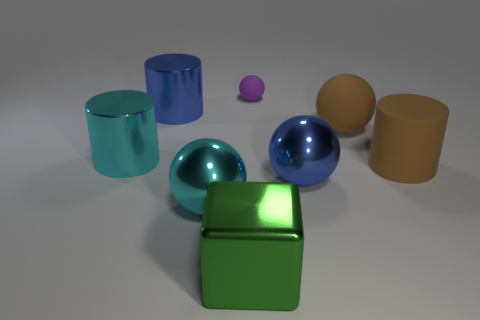Subtract all big matte spheres. How many spheres are left? 3 Subtract all brown spheres. How many spheres are left? 3 Subtract 1 spheres. How many spheres are left? 3 Subtract all green balls. Subtract all purple blocks. How many balls are left? 4 Add 1 purple rubber things. How many objects exist? 9 Subtract all cylinders. How many objects are left? 5 Add 4 cyan metal things. How many cyan metal things are left? 6 Add 1 big cyan shiny things. How many big cyan shiny things exist? 3 Subtract 1 purple balls. How many objects are left? 7 Subtract all blue cylinders. Subtract all green things. How many objects are left? 6 